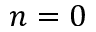Convert formula to latex. <formula><loc_0><loc_0><loc_500><loc_500>n = 0</formula> 